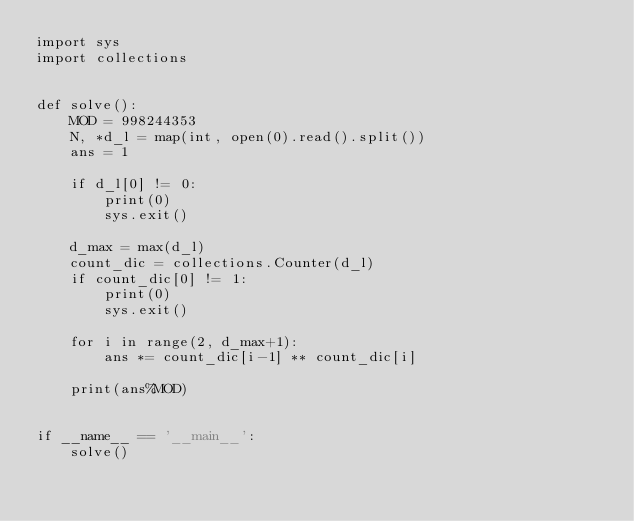<code> <loc_0><loc_0><loc_500><loc_500><_Python_>import sys
import collections


def solve():
    MOD = 998244353
    N, *d_l = map(int, open(0).read().split())
    ans = 1
    
    if d_l[0] != 0:
        print(0)
        sys.exit()
    
    d_max = max(d_l)
    count_dic = collections.Counter(d_l)
    if count_dic[0] != 1:
        print(0)
        sys.exit()
    
    for i in range(2, d_max+1):
        ans *= count_dic[i-1] ** count_dic[i]
    
    print(ans%MOD)


if __name__ == '__main__':
    solve()</code> 